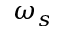<formula> <loc_0><loc_0><loc_500><loc_500>\omega _ { s }</formula> 